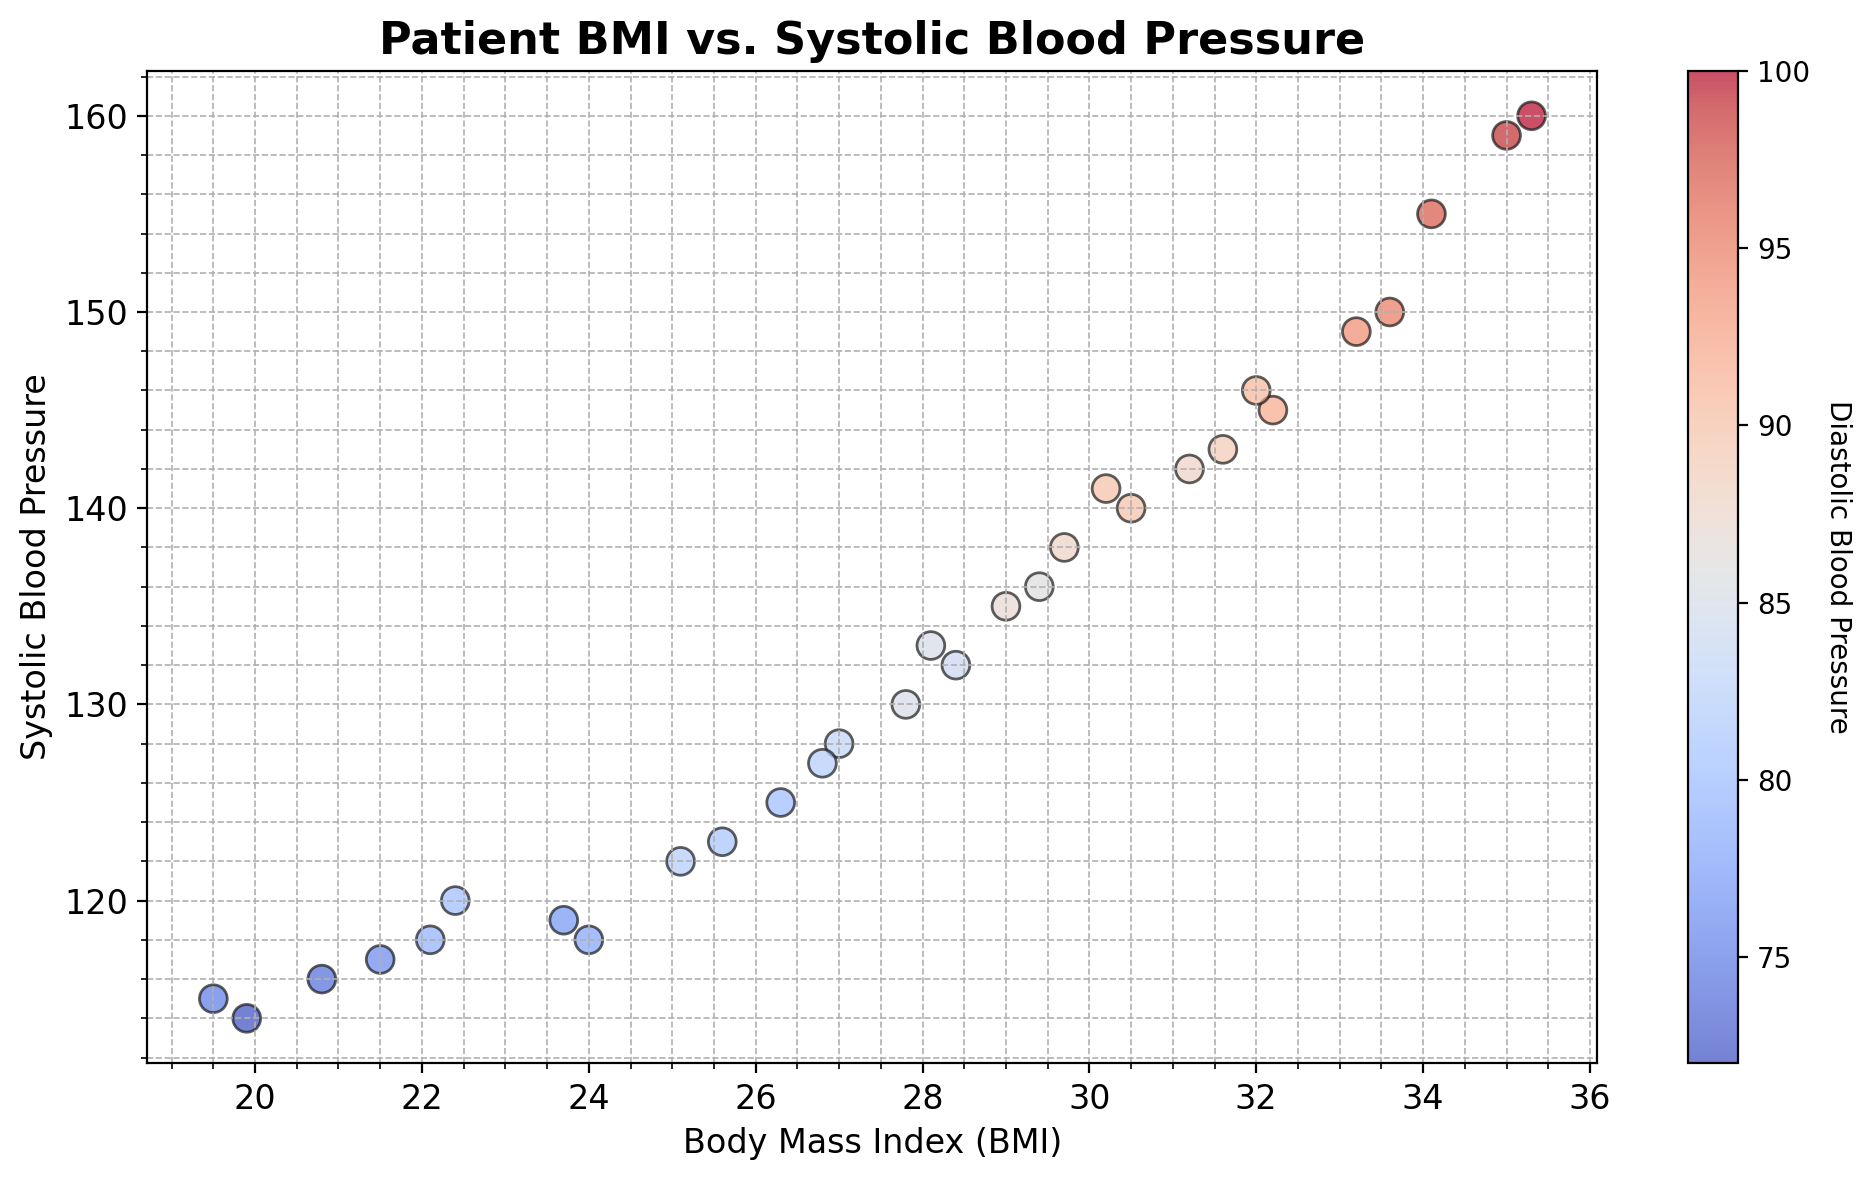What is the range of Systolic Blood Pressure values for patients with a BMI between 19 and 25? First, locate the data points with BMI values between 19 and 25 on the x-axis. Observe the corresponding Systolic Blood Pressure values on the y-axis for these points. The minimum value is 114 (for BMI 19.9) and the maximum value is 123 (for BMI 25.6).
Answer: 114-123 Do patients with higher BMIs generally have higher Systolic Blood Pressure levels? Examine the scatter plot trend from lower BMI to higher BMI values and observe the Systolic Blood Pressure values on the y-axis. Notice a general upward trend where higher BMIs correspond to higher Systolic Blood Pressure levels.
Answer: Yes Which patient has the highest Systolic Blood Pressure value and what is their BMI? Identify the highest point on the y-axis, which represents the maximum Systolic Blood Pressure. The highest value is 160, and the corresponding BMI is 35.3.
Answer: Patient with BMI 35.3 How many patients have a Systolic Blood Pressure below 130? Count the data points on the scatter plot that are below the 130 mark on the y-axis. There are 11 such points.
Answer: 11 What is the average Diastolic Blood Pressure for patients with a BMI above 30? First, single out the points for BMI values above 30 on the x-axis. The corresponding Diastolic values are 92, 89, 97, 91, 90, and 99. Sum these values and divide by their count: (92 + 89 + 97 + 91 + 90 + 99) / 6 = 93.
Answer: 93 Do any patients with a BMI below 21 have a Diastolic Blood Pressure higher than 80? Inspect data points with a BMI below 21 for their Diastolic Blood Pressure values. The highest Diastolic Blood Pressure below a BMI of 21 is 76.
Answer: No What is the Diastolic Blood Pressure range for patients with the highest BMI and the lowest BMI in the dataset? Locate the data points for the highest and lowest BMI values (35.3 and 19.5, respectively) and check their Diastolic Blood Pressure values. For BMI 35.3, the Diastolic BP is 100, and for BMI 19.5, it is 75. The range is 75-100.
Answer: 75-100 Is there a visible correlation between the color intensity of the points and their height on the y-axis? Examine whether higher points on the y-axis (representing higher Systolic Blood Pressure) are in darker colors (higher Diastolic Blood Pressure). There is a visible trend where higher points tend to be darker, indicating a positive correlation between Systolic and Diastolic Blood Pressures.
Answer: Yes Are there any outliers in the plot, where the Systolic Blood Pressure does not follow the general trend with BMI? Look for points significantly deviating from the upward trend of increasing Systolic BP with BMI. The point with BMI 27.0 and Systolic BP 128 could be considered an outlier as it is lower than nearby values.
Answer: Yes, BMI 27.0 How many patients have a Diastolic Blood Pressure equal to or exceeding 95? Count the points where the Diastolic Blood Pressure (color) is 95 or higher. There are 2 such points.
Answer: 2 